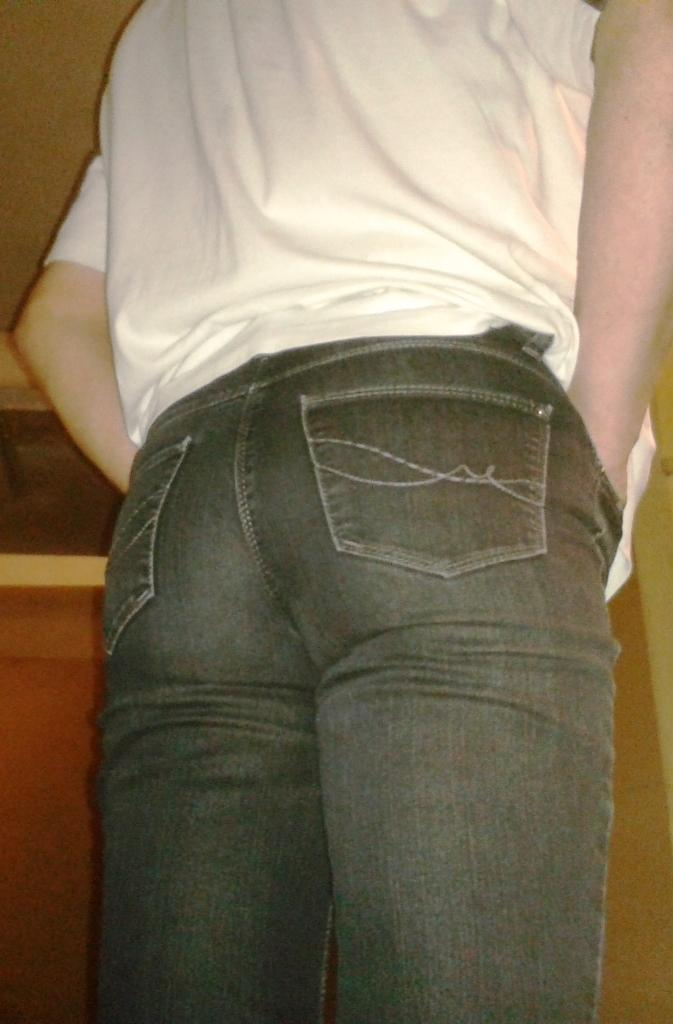What is the main subject of the image? There is a person in the image. Can you describe anything in the background of the image? There is an object in the background of the image. How many sisters does the person in the image have? There is no information about the person's sisters in the image, so we cannot determine the number of sisters they have. What type of birds can be seen flying in the image? There are no birds visible in the image. 